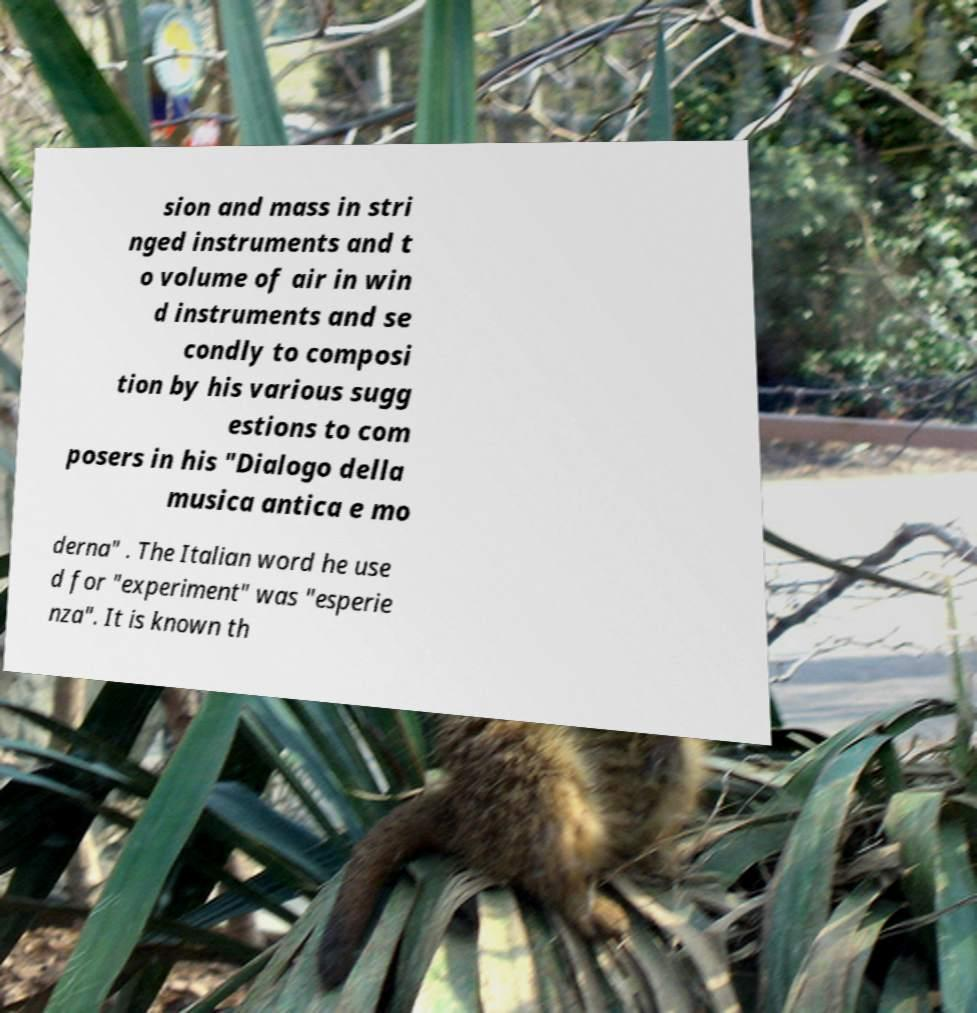Could you assist in decoding the text presented in this image and type it out clearly? sion and mass in stri nged instruments and t o volume of air in win d instruments and se condly to composi tion by his various sugg estions to com posers in his "Dialogo della musica antica e mo derna" . The Italian word he use d for "experiment" was "esperie nza". It is known th 